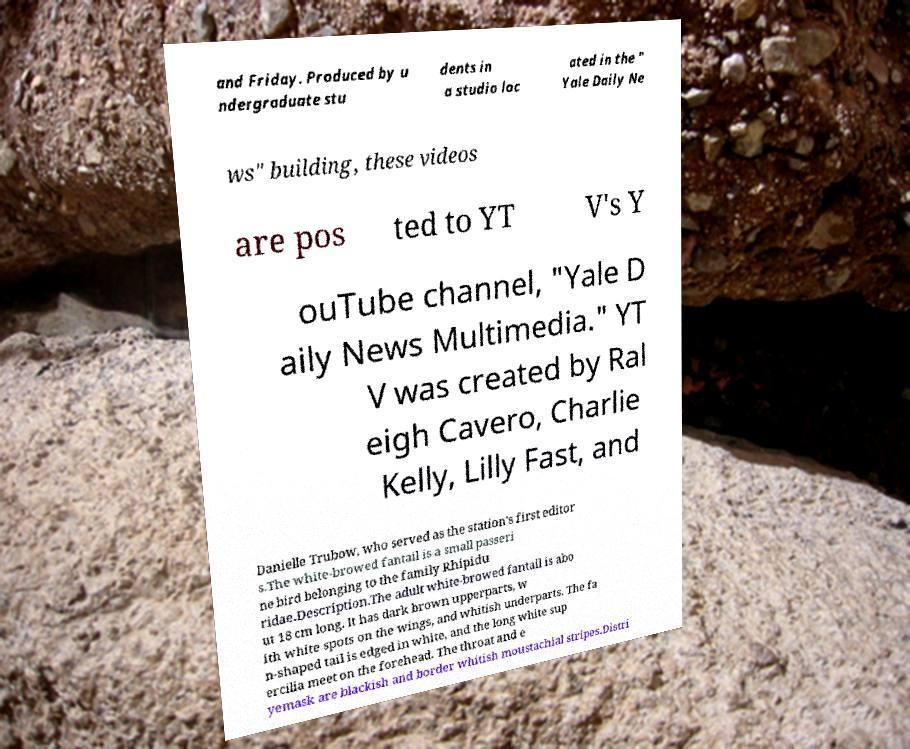Can you accurately transcribe the text from the provided image for me? and Friday. Produced by u ndergraduate stu dents in a studio loc ated in the " Yale Daily Ne ws" building, these videos are pos ted to YT V's Y ouTube channel, "Yale D aily News Multimedia." YT V was created by Ral eigh Cavero, Charlie Kelly, Lilly Fast, and Danielle Trubow, who served as the station's first editor s.The white-browed fantail is a small passeri ne bird belonging to the family Rhipidu ridae.Description.The adult white-browed fantail is abo ut 18 cm long. It has dark brown upperparts, w ith white spots on the wings, and whitish underparts. The fa n-shaped tail is edged in white, and the long white sup ercilia meet on the forehead. The throat and e yemask are blackish and border whitish moustachial stripes.Distri 